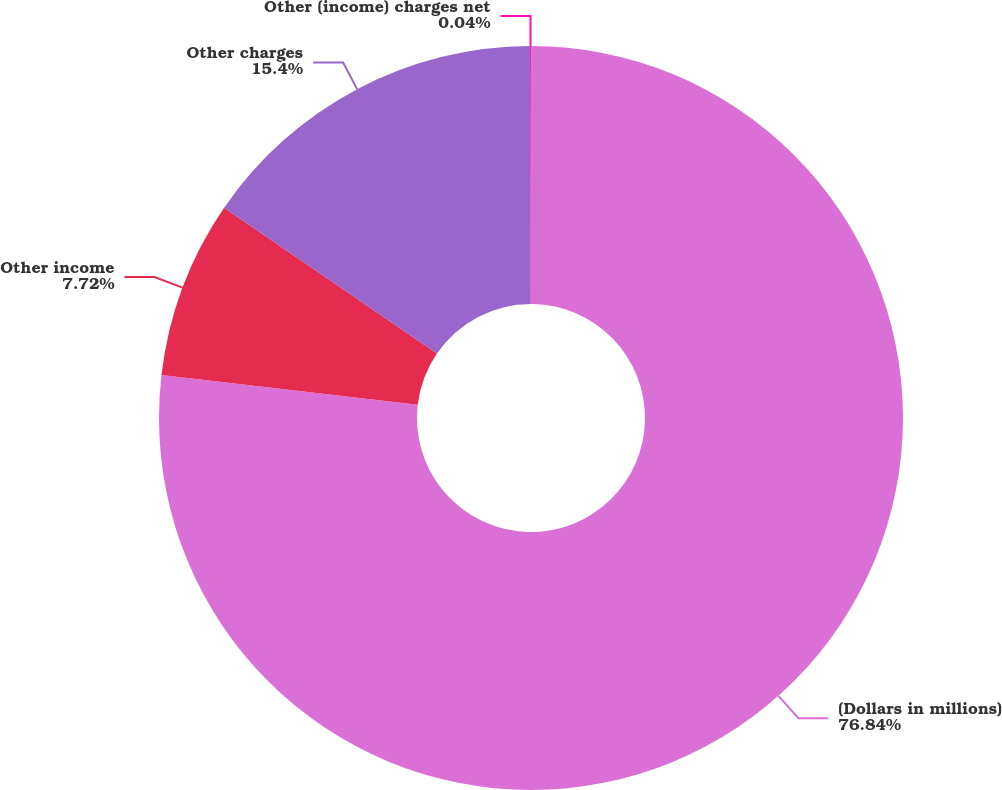Convert chart. <chart><loc_0><loc_0><loc_500><loc_500><pie_chart><fcel>(Dollars in millions)<fcel>Other income<fcel>Other charges<fcel>Other (income) charges net<nl><fcel>76.84%<fcel>7.72%<fcel>15.4%<fcel>0.04%<nl></chart> 